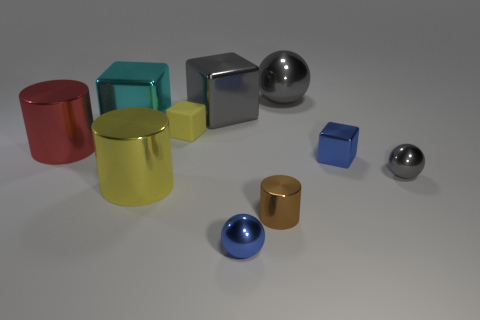Subtract all large gray metal blocks. How many blocks are left? 3 Subtract 3 balls. How many balls are left? 0 Subtract all cylinders. How many objects are left? 7 Subtract all yellow cylinders. Subtract all yellow spheres. How many cylinders are left? 2 Subtract all cyan balls. How many brown cylinders are left? 1 Subtract all big yellow objects. Subtract all purple metallic cubes. How many objects are left? 9 Add 1 tiny rubber things. How many tiny rubber things are left? 2 Add 5 small yellow rubber spheres. How many small yellow rubber spheres exist? 5 Subtract all yellow blocks. How many blocks are left? 3 Subtract 1 gray cubes. How many objects are left? 9 